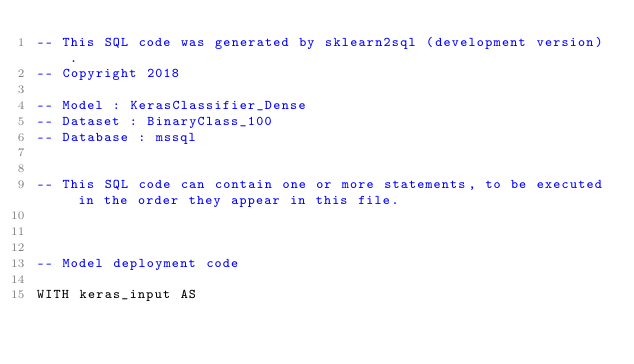Convert code to text. <code><loc_0><loc_0><loc_500><loc_500><_SQL_>-- This SQL code was generated by sklearn2sql (development version).
-- Copyright 2018

-- Model : KerasClassifier_Dense
-- Dataset : BinaryClass_100
-- Database : mssql


-- This SQL code can contain one or more statements, to be executed in the order they appear in this file.



-- Model deployment code

WITH keras_input AS </code> 